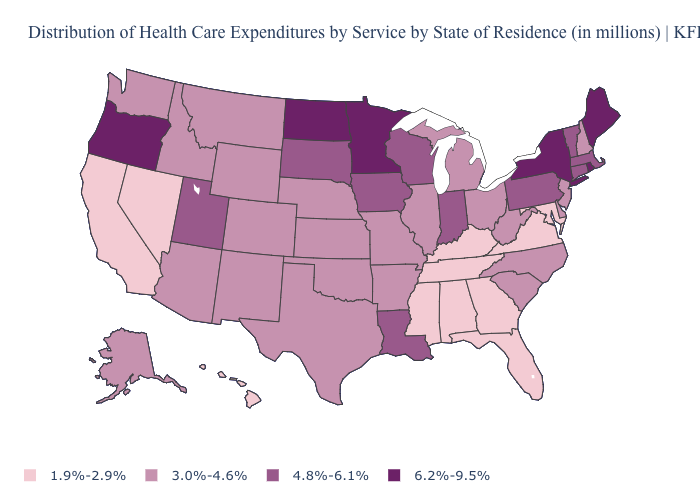Does Wyoming have a lower value than Vermont?
Quick response, please. Yes. Is the legend a continuous bar?
Answer briefly. No. Name the states that have a value in the range 3.0%-4.6%?
Concise answer only. Alaska, Arizona, Arkansas, Colorado, Delaware, Idaho, Illinois, Kansas, Michigan, Missouri, Montana, Nebraska, New Hampshire, New Jersey, New Mexico, North Carolina, Ohio, Oklahoma, South Carolina, Texas, Washington, West Virginia, Wyoming. What is the value of Connecticut?
Be succinct. 4.8%-6.1%. Does Alabama have the same value as Iowa?
Concise answer only. No. Does Utah have the lowest value in the West?
Short answer required. No. What is the lowest value in the USA?
Answer briefly. 1.9%-2.9%. Name the states that have a value in the range 3.0%-4.6%?
Keep it brief. Alaska, Arizona, Arkansas, Colorado, Delaware, Idaho, Illinois, Kansas, Michigan, Missouri, Montana, Nebraska, New Hampshire, New Jersey, New Mexico, North Carolina, Ohio, Oklahoma, South Carolina, Texas, Washington, West Virginia, Wyoming. What is the highest value in the USA?
Give a very brief answer. 6.2%-9.5%. Does Louisiana have the highest value in the USA?
Keep it brief. No. What is the value of Iowa?
Short answer required. 4.8%-6.1%. Is the legend a continuous bar?
Short answer required. No. Among the states that border Minnesota , does North Dakota have the highest value?
Answer briefly. Yes. What is the value of Mississippi?
Give a very brief answer. 1.9%-2.9%. Does the map have missing data?
Answer briefly. No. 